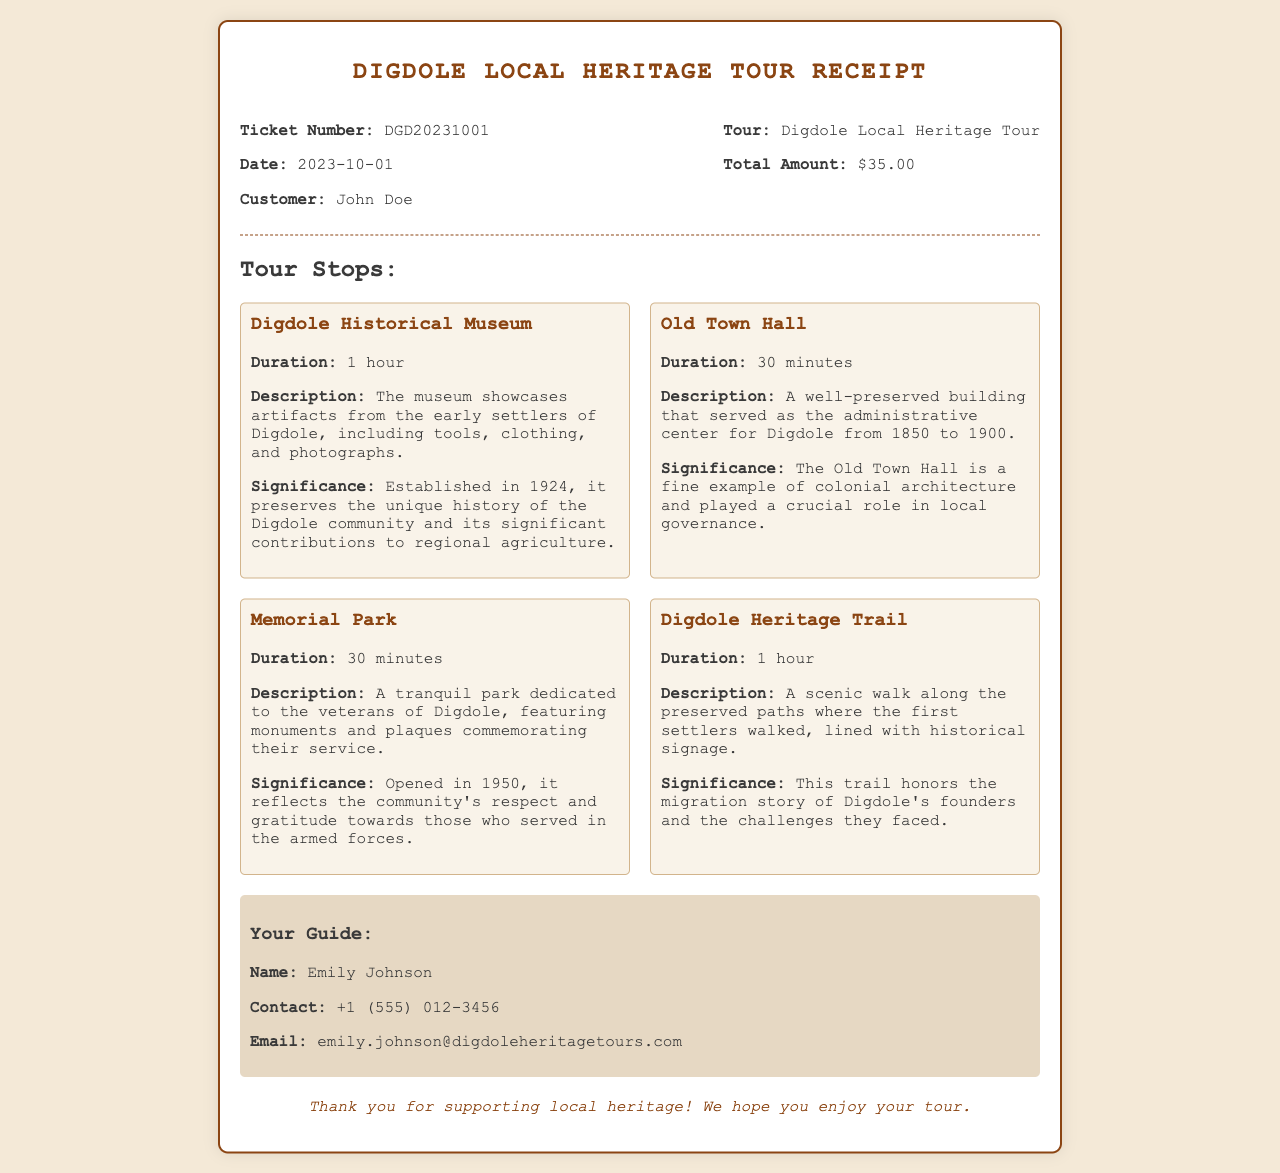What is the ticket number? The ticket number is specifically mentioned in the receipt under the header section.
Answer: DGD20231001 Who is the customer? The name of the customer is provided in the receipt near the ticket number.
Answer: John Doe What is the total amount? The total amount is stated in the header section of the receipt.
Answer: $35.00 How long is the Digdole Historical Museum visit? The duration of the visit is indicated in the tour stops section for this specific stop.
Answer: 1 hour What significant year is mentioned for the establishment of the Digdole Historical Museum? The year the museum was established is provided in the significance section for the corresponding stop.
Answer: 1924 What was the function of the Old Town Hall? The function is described in the Old Town Hall stop section of the receipt.
Answer: Administrative center Who is the tour guide? The name of the tour guide is detailed in the guide information section.
Answer: Emily Johnson What is the guide's contact number? The contact number for the guide is provided in the guide information area of the receipt.
Answer: +1 (555) 012-3456 What is the significance of Memorial Park? The significance is outlined in the Memorial Park stop section and pertains to veterans.
Answer: Community's respect for veterans 